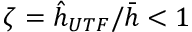<formula> <loc_0><loc_0><loc_500><loc_500>\zeta = \hat { h } _ { U T F } / \bar { h } < 1</formula> 